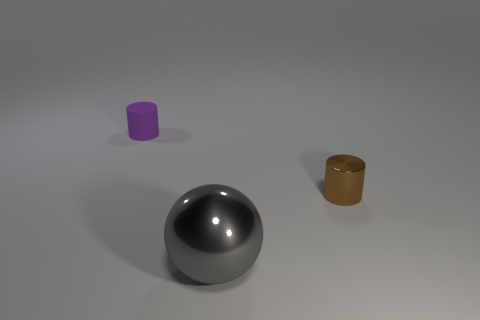Add 3 gray metal things. How many objects exist? 6 Subtract all balls. How many objects are left? 2 Add 3 small purple rubber objects. How many small purple rubber objects are left? 4 Add 2 small matte things. How many small matte things exist? 3 Subtract 1 purple cylinders. How many objects are left? 2 Subtract all small cylinders. Subtract all yellow balls. How many objects are left? 1 